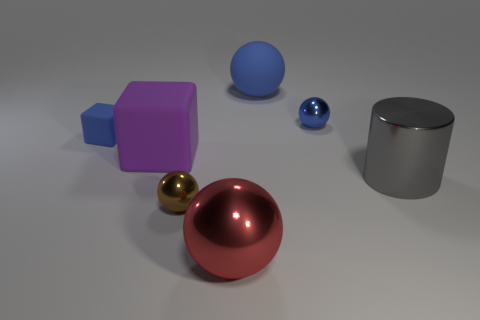Subtract all purple blocks. How many blue spheres are left? 2 Add 1 big metal things. How many objects exist? 8 Subtract 1 spheres. How many spheres are left? 3 Subtract all blue matte balls. How many balls are left? 3 Subtract all brown balls. How many balls are left? 3 Subtract all blocks. How many objects are left? 5 Subtract all purple balls. Subtract all purple cylinders. How many balls are left? 4 Add 4 blue things. How many blue things exist? 7 Subtract 0 yellow cubes. How many objects are left? 7 Subtract all gray spheres. Subtract all brown metallic spheres. How many objects are left? 6 